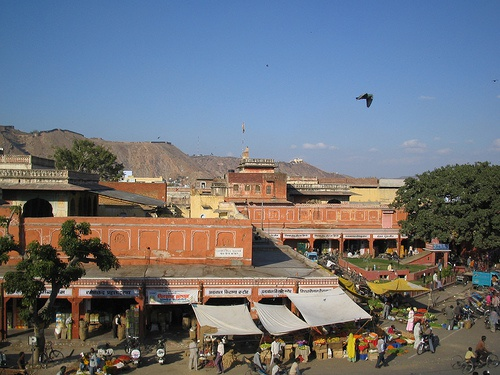Describe the objects in this image and their specific colors. I can see people in blue, black, gray, and darkgreen tones, bicycle in blue, black, and gray tones, people in blue, gold, olive, and black tones, motorcycle in blue, black, gray, darkgray, and lightgray tones, and motorcycle in blue, black, gray, darkgray, and ivory tones in this image. 